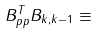<formula> <loc_0><loc_0><loc_500><loc_500>B _ { p p } ^ { T } B _ { k , k - 1 } \equiv</formula> 